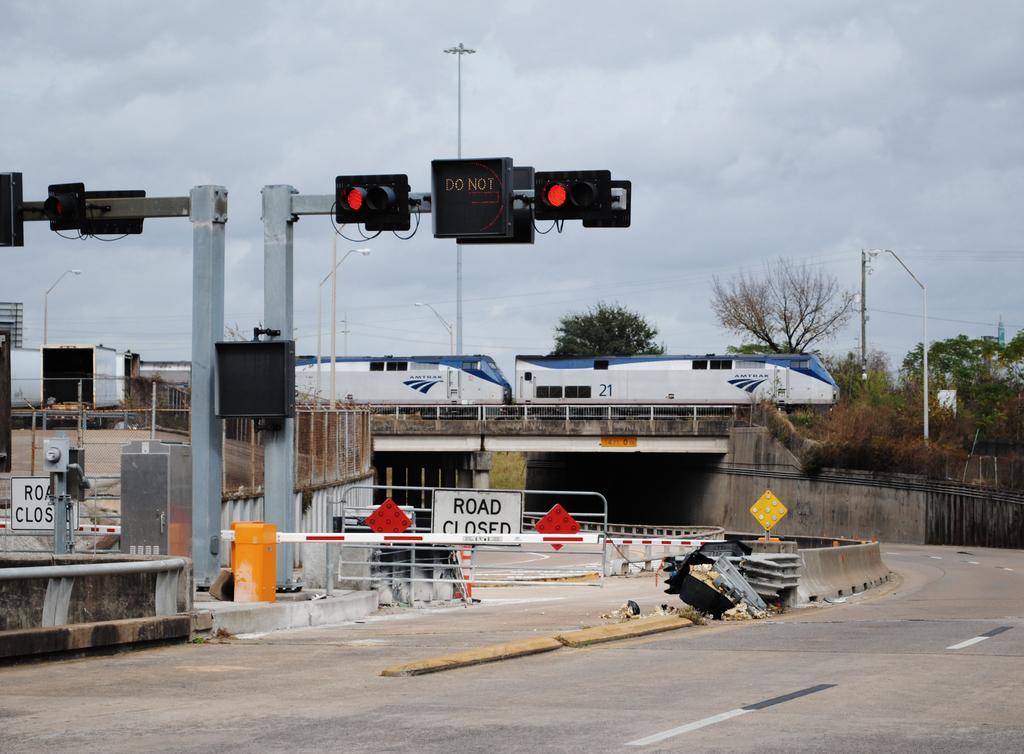Please provide a concise description of this image. In this picture there is a train on the railway track over the bridge. On the road we can see the gate, traffic signals, fencing, traffic cones and dustbin. in the background we can see the electric poles, street lights, trees and building. At the top we can see sky and clouds. 